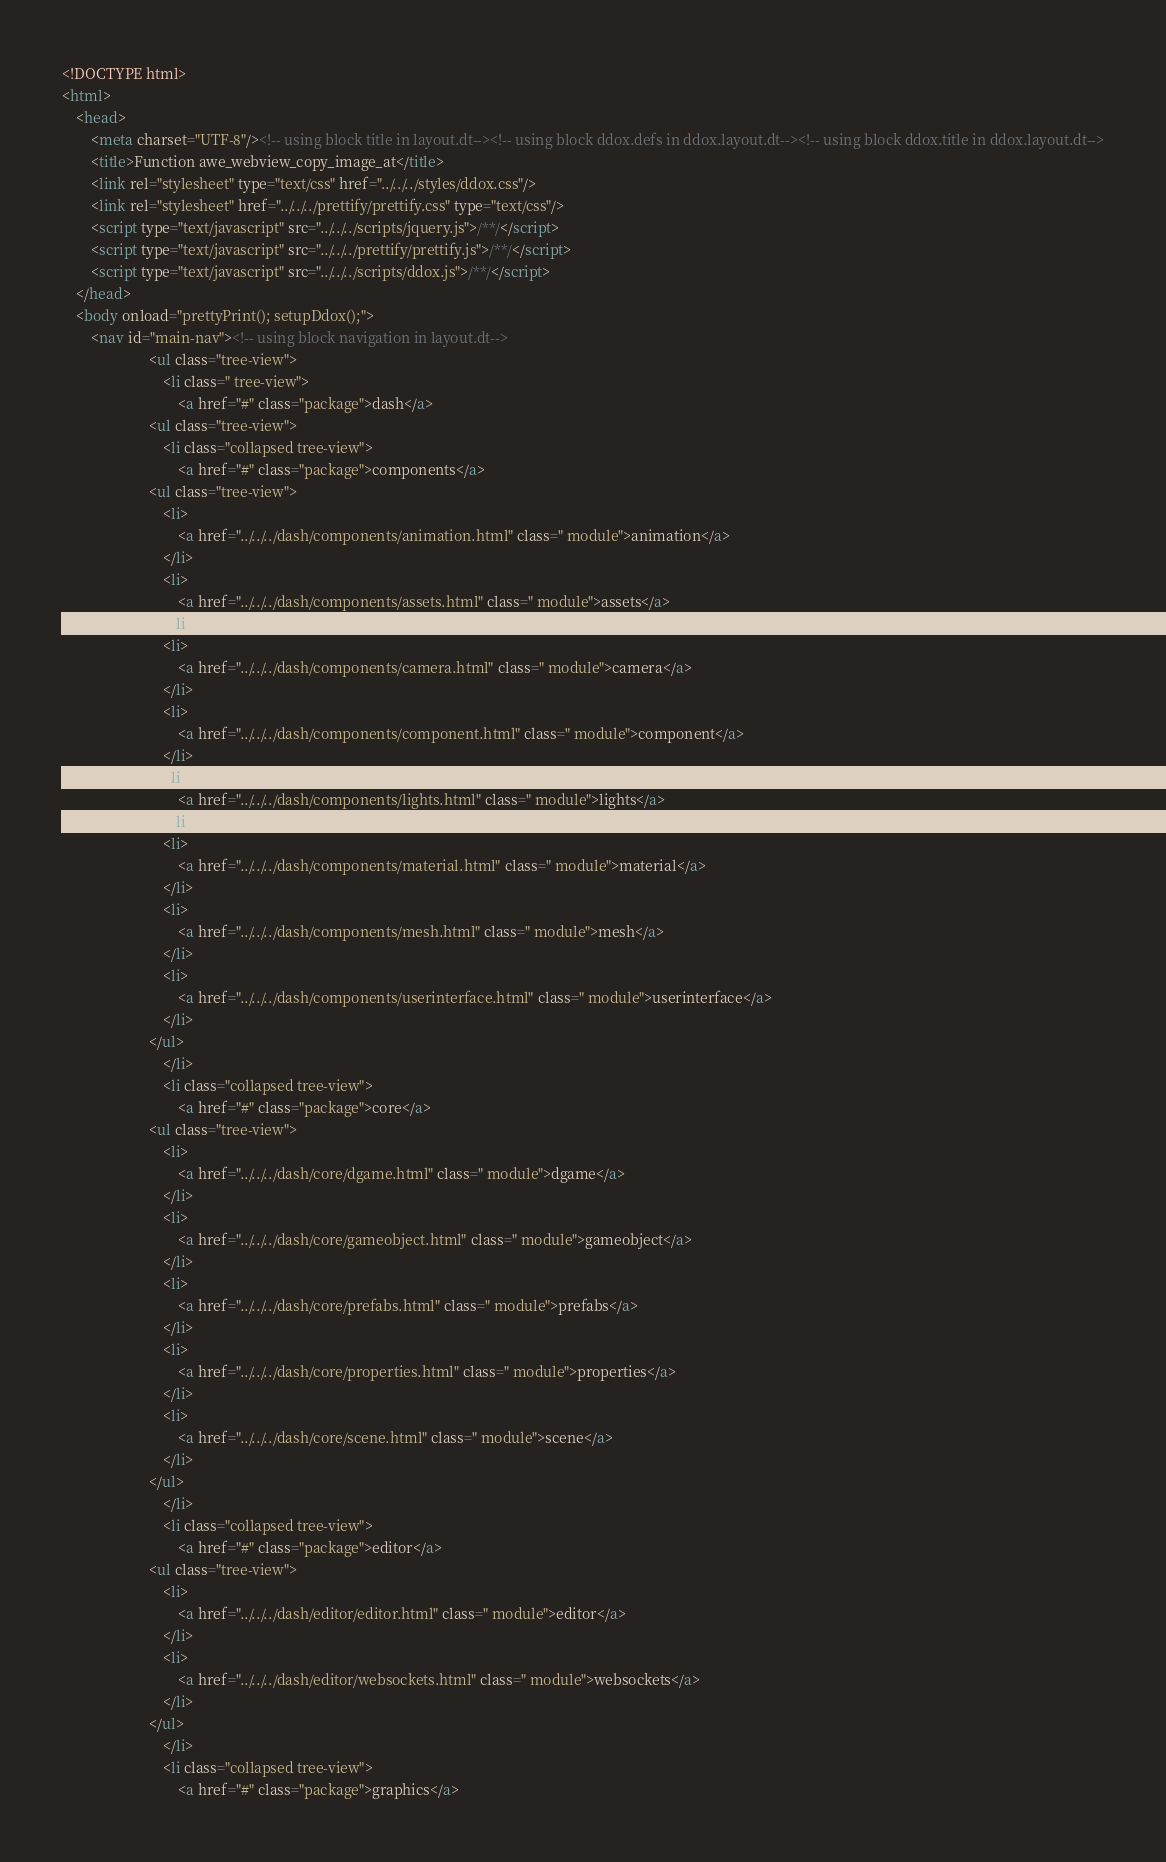<code> <loc_0><loc_0><loc_500><loc_500><_HTML_>
<!DOCTYPE html>
<html>
	<head>
		<meta charset="UTF-8"/><!-- using block title in layout.dt--><!-- using block ddox.defs in ddox.layout.dt--><!-- using block ddox.title in ddox.layout.dt-->
		<title>Function awe_webview_copy_image_at</title>
		<link rel="stylesheet" type="text/css" href="../../../styles/ddox.css"/>
		<link rel="stylesheet" href="../../../prettify/prettify.css" type="text/css"/>
		<script type="text/javascript" src="../../../scripts/jquery.js">/**/</script>
		<script type="text/javascript" src="../../../prettify/prettify.js">/**/</script>
		<script type="text/javascript" src="../../../scripts/ddox.js">/**/</script>
	</head>
	<body onload="prettyPrint(); setupDdox();">
		<nav id="main-nav"><!-- using block navigation in layout.dt-->
						<ul class="tree-view">
							<li class=" tree-view">
								<a href="#" class="package">dash</a>
						<ul class="tree-view">
							<li class="collapsed tree-view">
								<a href="#" class="package">components</a>
						<ul class="tree-view">
							<li>
								<a href="../../../dash/components/animation.html" class=" module">animation</a>
							</li>
							<li>
								<a href="../../../dash/components/assets.html" class=" module">assets</a>
							</li>
							<li>
								<a href="../../../dash/components/camera.html" class=" module">camera</a>
							</li>
							<li>
								<a href="../../../dash/components/component.html" class=" module">component</a>
							</li>
							<li>
								<a href="../../../dash/components/lights.html" class=" module">lights</a>
							</li>
							<li>
								<a href="../../../dash/components/material.html" class=" module">material</a>
							</li>
							<li>
								<a href="../../../dash/components/mesh.html" class=" module">mesh</a>
							</li>
							<li>
								<a href="../../../dash/components/userinterface.html" class=" module">userinterface</a>
							</li>
						</ul>
							</li>
							<li class="collapsed tree-view">
								<a href="#" class="package">core</a>
						<ul class="tree-view">
							<li>
								<a href="../../../dash/core/dgame.html" class=" module">dgame</a>
							</li>
							<li>
								<a href="../../../dash/core/gameobject.html" class=" module">gameobject</a>
							</li>
							<li>
								<a href="../../../dash/core/prefabs.html" class=" module">prefabs</a>
							</li>
							<li>
								<a href="../../../dash/core/properties.html" class=" module">properties</a>
							</li>
							<li>
								<a href="../../../dash/core/scene.html" class=" module">scene</a>
							</li>
						</ul>
							</li>
							<li class="collapsed tree-view">
								<a href="#" class="package">editor</a>
						<ul class="tree-view">
							<li>
								<a href="../../../dash/editor/editor.html" class=" module">editor</a>
							</li>
							<li>
								<a href="../../../dash/editor/websockets.html" class=" module">websockets</a>
							</li>
						</ul>
							</li>
							<li class="collapsed tree-view">
								<a href="#" class="package">graphics</a></code> 